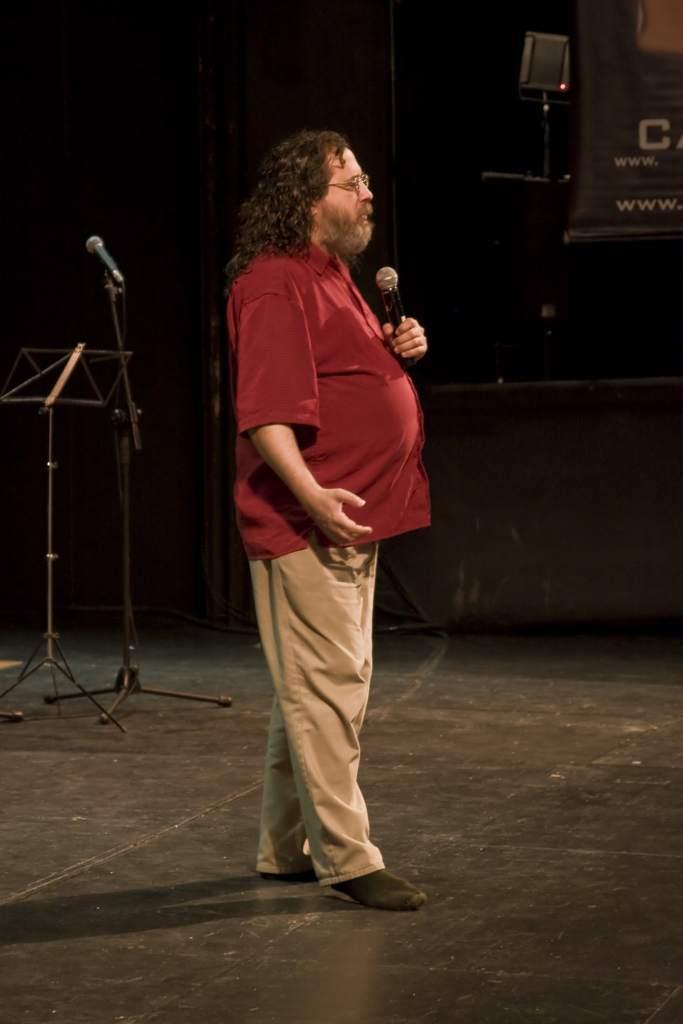How would you summarize this image in a sentence or two? In this image there is a man standing on the floor by holding the mic. In the background there is a stand and a mic stand. On the right side top there is a banner. 